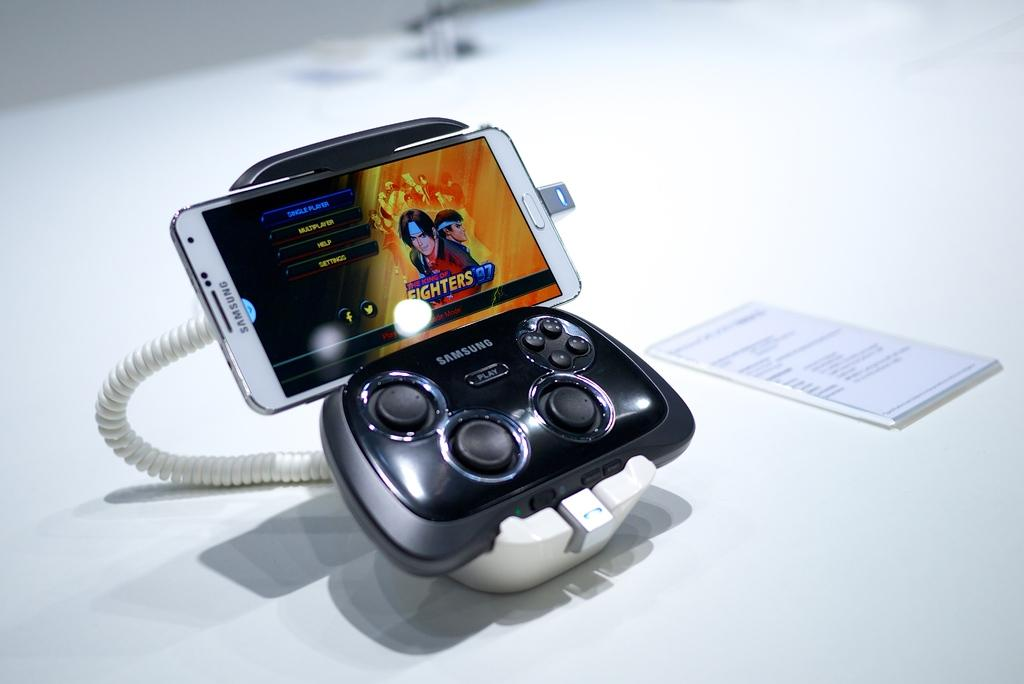<image>
Give a short and clear explanation of the subsequent image. A white smartphone connected to a black samsung controller 